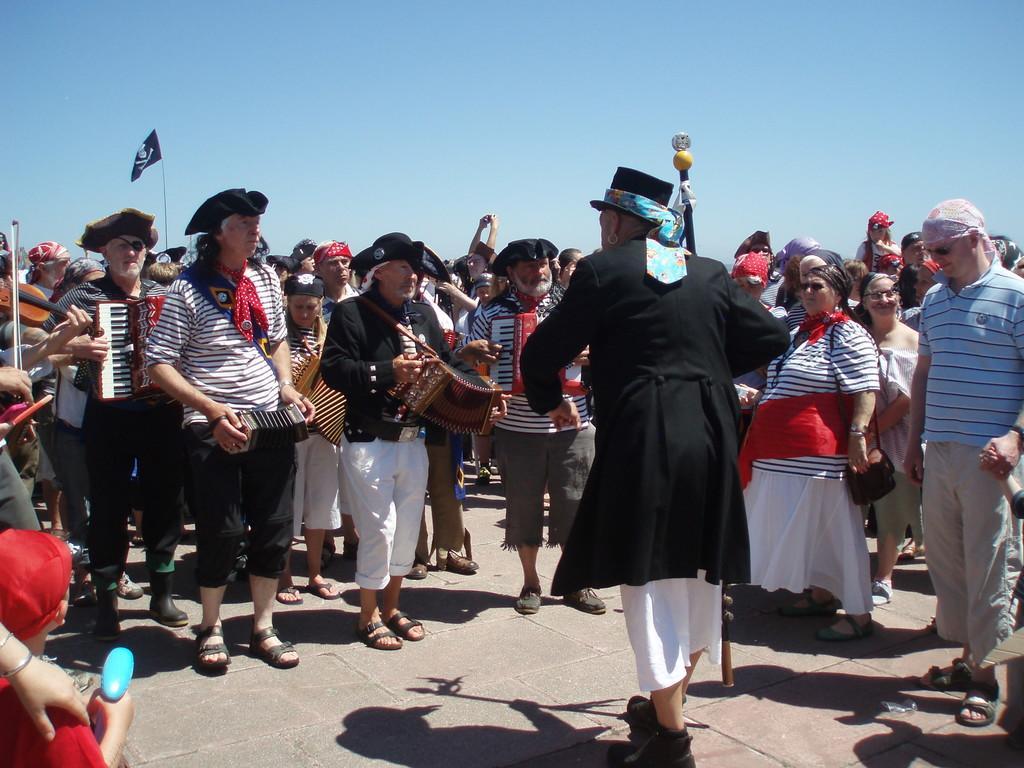Please provide a concise description of this image. Here we can see some persons standing on the road. And he is doing something and these people are looking at him. And he is playing with some musical instrument. And this is the sky, and there is a flag. 